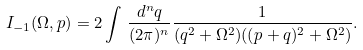Convert formula to latex. <formula><loc_0><loc_0><loc_500><loc_500>I _ { - 1 } ( \Omega , p ) = 2 \int \, \frac { d ^ { n } q } { ( 2 \pi ) ^ { n } } \frac { 1 } { ( q ^ { 2 } + \Omega ^ { 2 } ) ( ( p + q ) ^ { 2 } + \Omega ^ { 2 } ) } .</formula> 